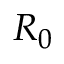Convert formula to latex. <formula><loc_0><loc_0><loc_500><loc_500>R _ { 0 }</formula> 